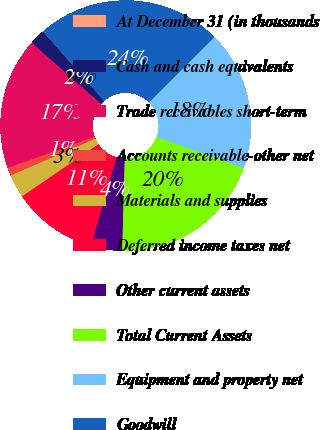Convert chart. <chart><loc_0><loc_0><loc_500><loc_500><pie_chart><fcel>At December 31 (in thousands<fcel>Cash and cash equivalents<fcel>Trade receivables short-term<fcel>Accounts receivable-other net<fcel>Materials and supplies<fcel>Deferred income taxes net<fcel>Other current assets<fcel>Total Current Assets<fcel>Equipment and property net<fcel>Goodwill<nl><fcel>0.04%<fcel>2.03%<fcel>16.98%<fcel>1.03%<fcel>3.02%<fcel>11.0%<fcel>4.02%<fcel>19.96%<fcel>17.97%<fcel>23.95%<nl></chart> 